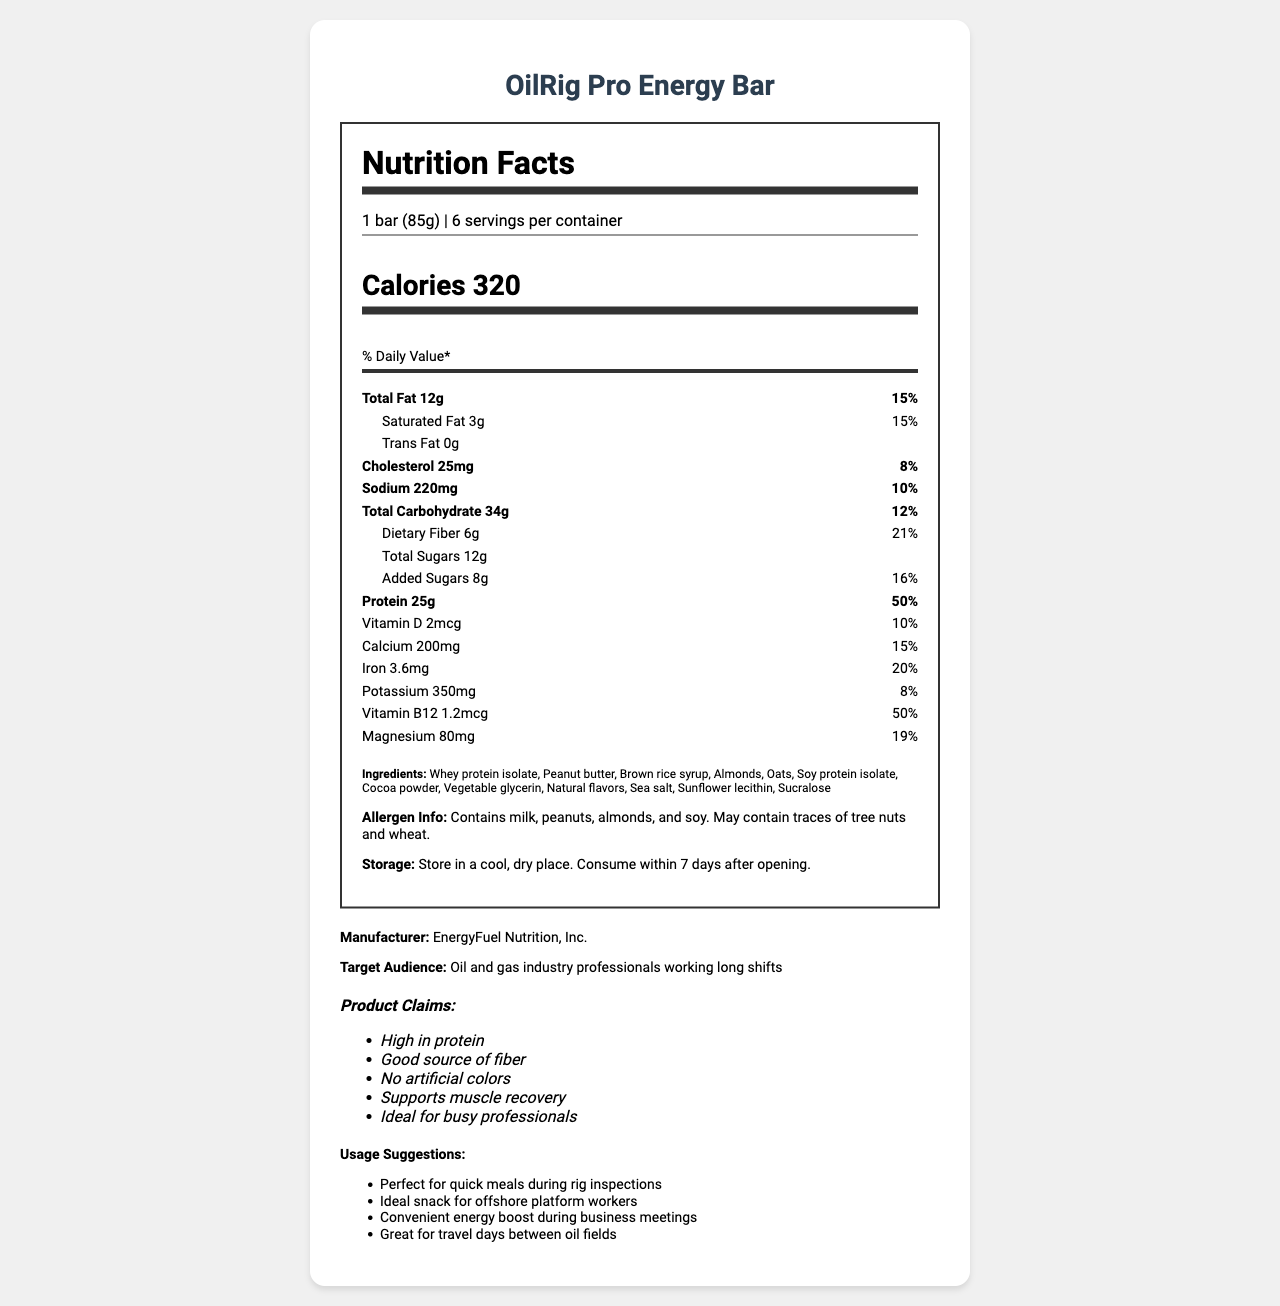What is the serving size of the OilRig Pro Energy Bar? The serving size is clearly labeled as "1 bar (85g)" at the beginning of the nutrition label.
Answer: 1 bar (85g) How many servings are there per container? The serving information at the top of the nutrition label states that there are 6 servings per container.
Answer: 6 How many calories are in one serving of the OilRig Pro Energy Bar? The nutrition label lists the calories information clearly as "Calories 320."
Answer: 320 What is the total fat content and its daily value percentage? The total fat content is listed as "Total Fat 12g" with a daily value of "15%" on the nutrition label.
Answer: 12g (15%) How much protein does the OilRig Pro Energy Bar provide per serving? The protein content is directly indicated as "Protein 25g" with a daily value of "50%."
Answer: 25g What is the daily value percentage of dietary fiber? The nutrition label lists "Dietary Fiber 6g" with a daily value of "21%."
Answer: 21% How much cholesterol does the bar contain? A. 10mg B. 25mg C. 45mg D. 60mg The cholesterol amount is specified in the nutrition label as "Cholesterol 25mg."
Answer: B. 25mg Which of the following ingredients is not included in the OilRig Pro Energy Bar? I. Almonds II. Brown rice syrup III. Corn syrup IV. Sea salt The list of ingredients includes almonds, brown rice syrup, and sea salt, but not corn syrup.
Answer: III. Corn syrup Does the product contain artificial colors? One of the product claims specifically states "No artificial colors."
Answer: No Can you consume the OilRig Pro Energy Bar after 10 days of opening if stored properly? The storage instructions advise consuming within 7 days after opening.
Answer: No Can individuals with tree nut allergies safely consume this product? The allergen info states that it "May contain traces of tree nuts," so it might not be safe.
Answer: Not enough information What specific group of professionals is this energy bar designed for? The target audience is specified as "Oil and gas industry professionals working long shifts."
Answer: Oil and gas industry professionals working long shifts Summarize the main idea of the document. The explanation includes all major sections of the document highlighting nutrition facts, product claims, target audience, and practical use cases, which together communicate the main purpose and benefits of the product.
Answer: The document provides detailed nutrition facts, ingredients, allergen information, storage instructions, and targeted use cases for the OilRig Pro Energy Bar, a high-protein meal replacement bar designed for busy professionals in the oil and gas industry. The bar is marketed for its high protein, fiber content, and various nutrition benefits, making it a convenient and healthy option for those with demanding work schedules. 